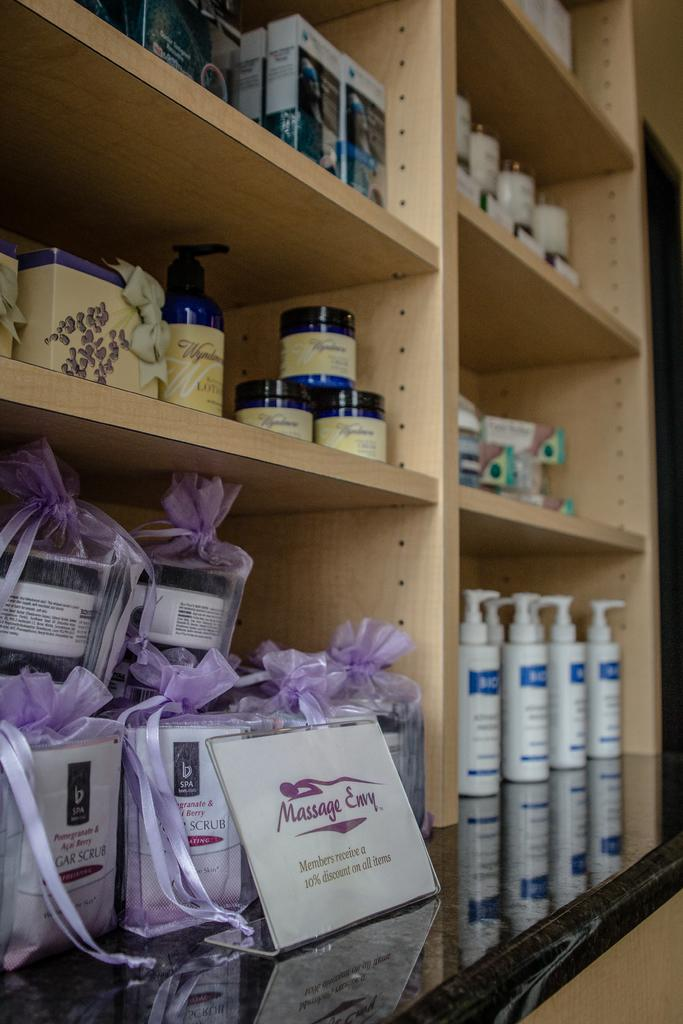What type of objects can be seen in the image? There are bottles and boxes in the image. What is the arrangement of some objects in the image? There are objects on rails in the image. What is the purpose of the name board in the image? The name board on a platform in the image is likely used for identifying the location or station. What can be seen in the background of the image? There is a wall visible in the background of the image. How does the image show support for those who are coughing? The image does not show support for those who are coughing; it features bottles, boxes, objects on rails, a name board, and a wall. 